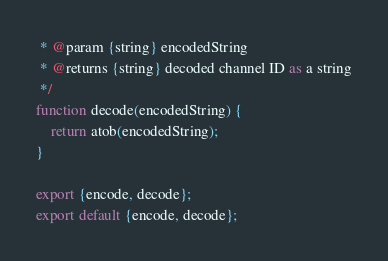Convert code to text. <code><loc_0><loc_0><loc_500><loc_500><_JavaScript_> * @param {string} encodedString 
 * @returns {string} decoded channel ID as a string
 */
function decode(encodedString) {
    return atob(encodedString);
}

export {encode, decode};
export default {encode, decode};</code> 